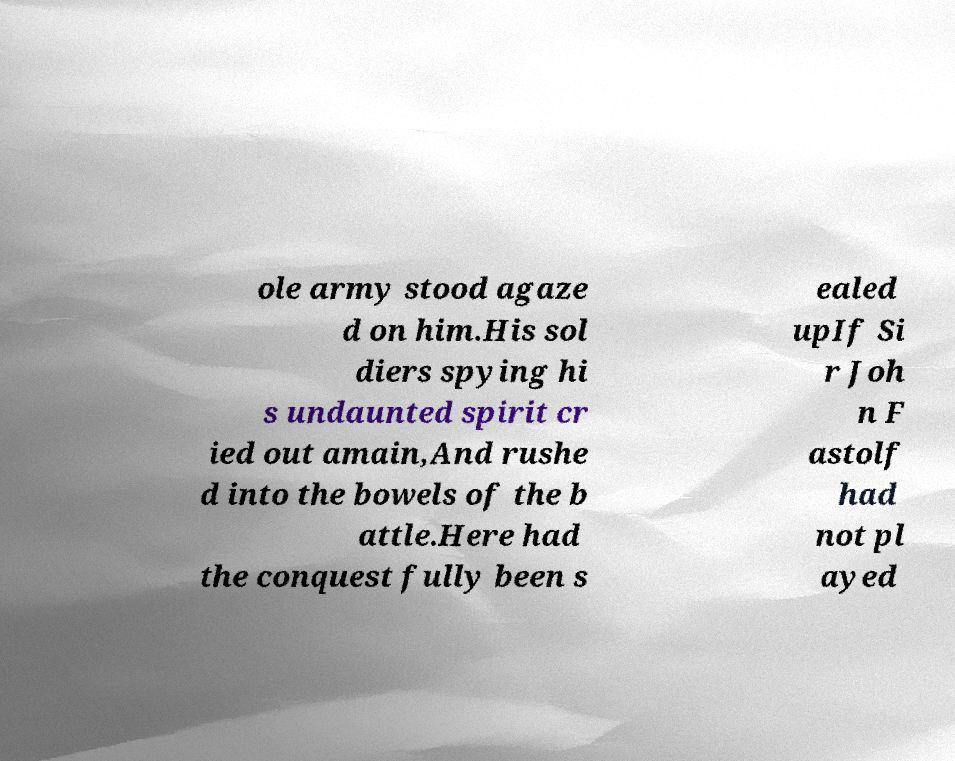Could you assist in decoding the text presented in this image and type it out clearly? ole army stood agaze d on him.His sol diers spying hi s undaunted spirit cr ied out amain,And rushe d into the bowels of the b attle.Here had the conquest fully been s ealed upIf Si r Joh n F astolf had not pl ayed 